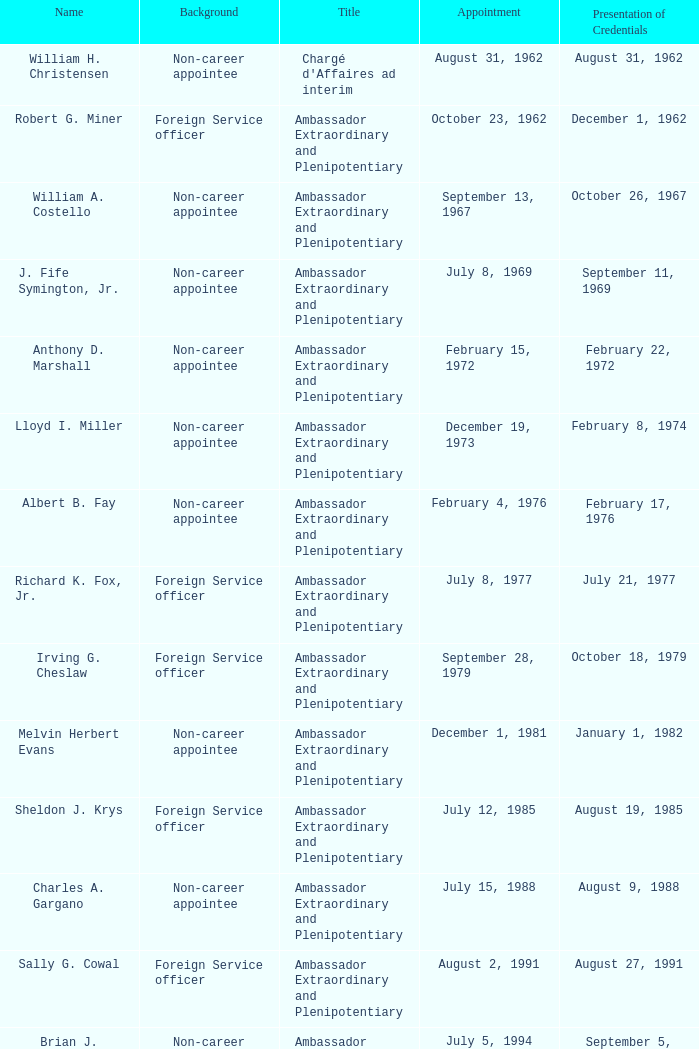When did Robert G. Miner present his credentials? December 1, 1962. 